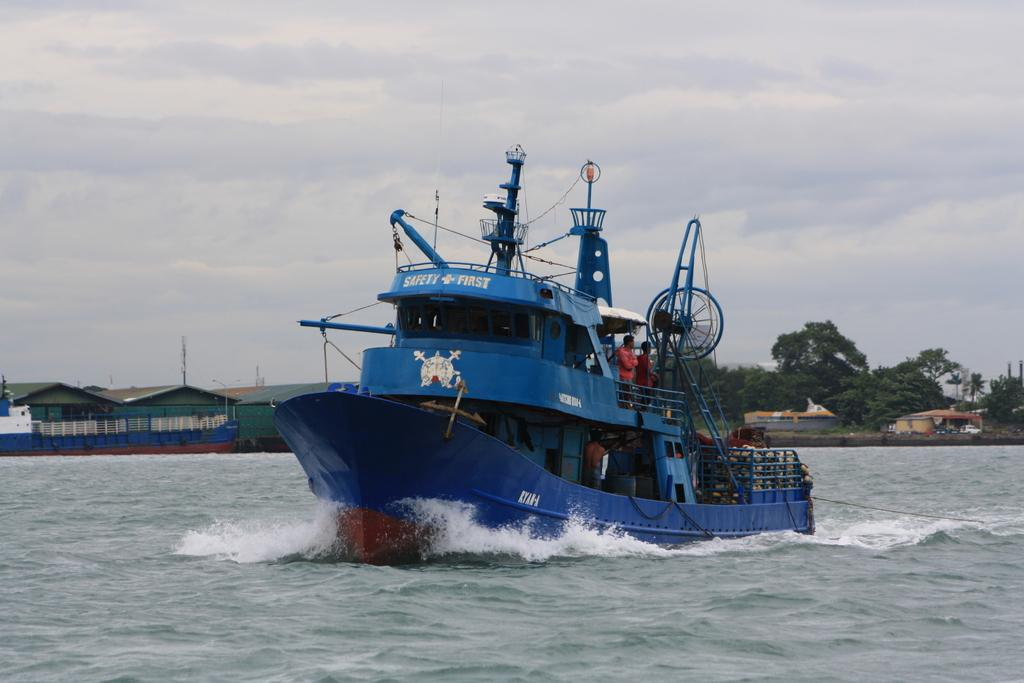What is the main subject of the image? The main subject of the image is a ship visible on the lake. Can you describe the person on the ship? Yes, there is a person visible on the ship. What is visible at the top of the image? The sky is visible at the top of the image. What other structures or objects can be seen in the middle of the image? Trees and houses are present in the middle of the image. What type of error can be seen in the image? There is no error present in the image; it is a clear depiction of a ship on a lake with a person on board, surrounded by trees and houses. What type of robin can be seen in the image? There are no birds, including robins, present in the image. 